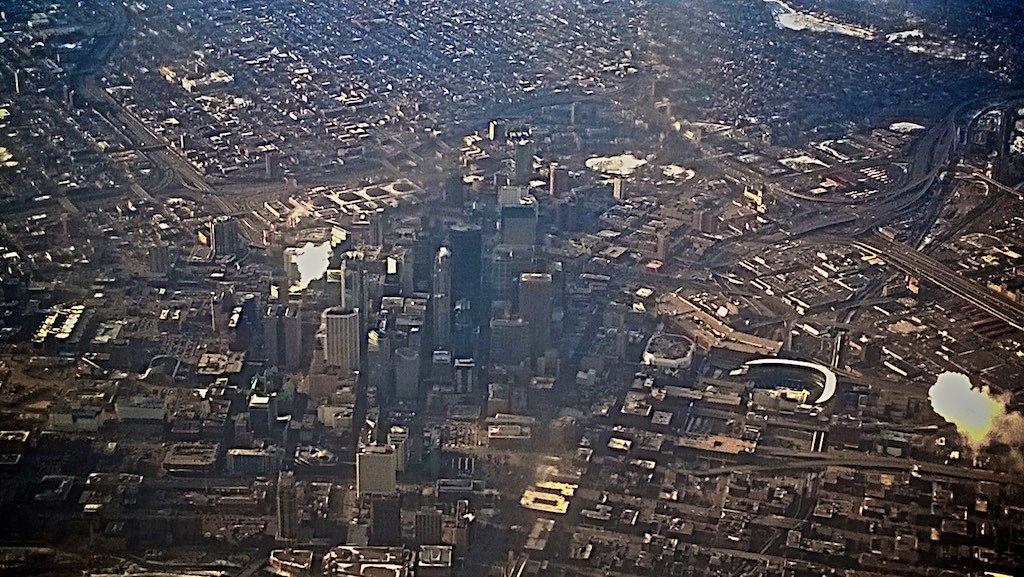Describe this image in one or two sentences. In this picture i can see the city. In that i can see many skyscrapers, buildings, road and vehicles. On the right i can see the fire and smoke which is coming from the factory. 